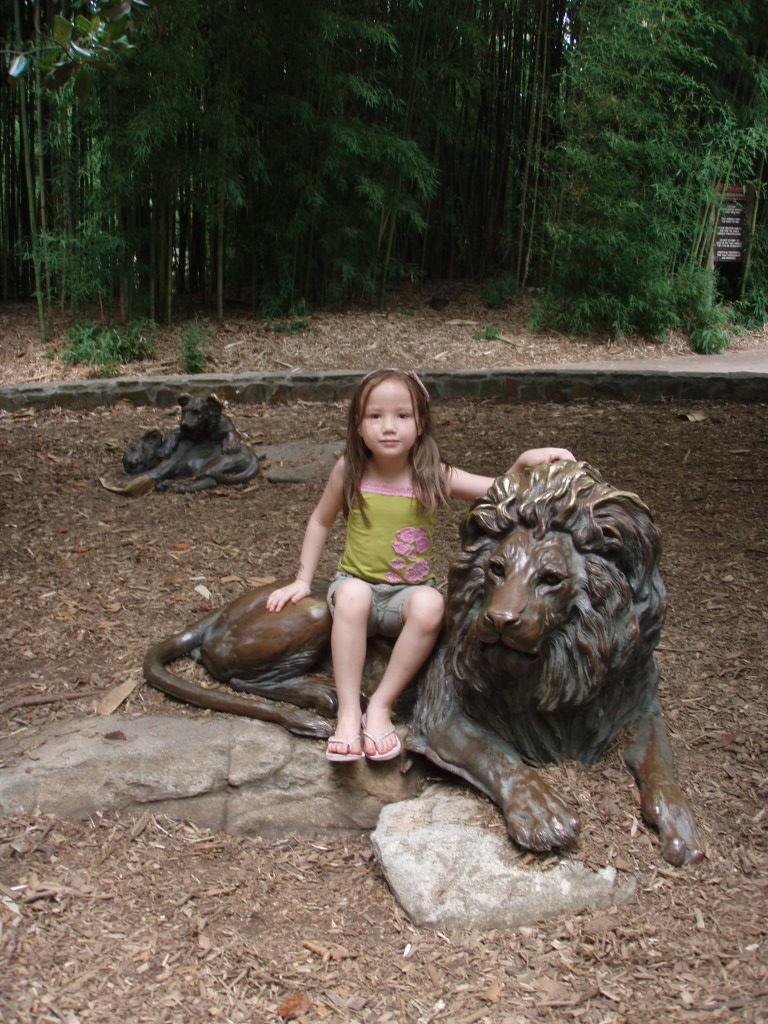Please provide a concise description of this image. This image consists of trees at the top. There are statues of animals in the middle. On that there is a kid sitting. 